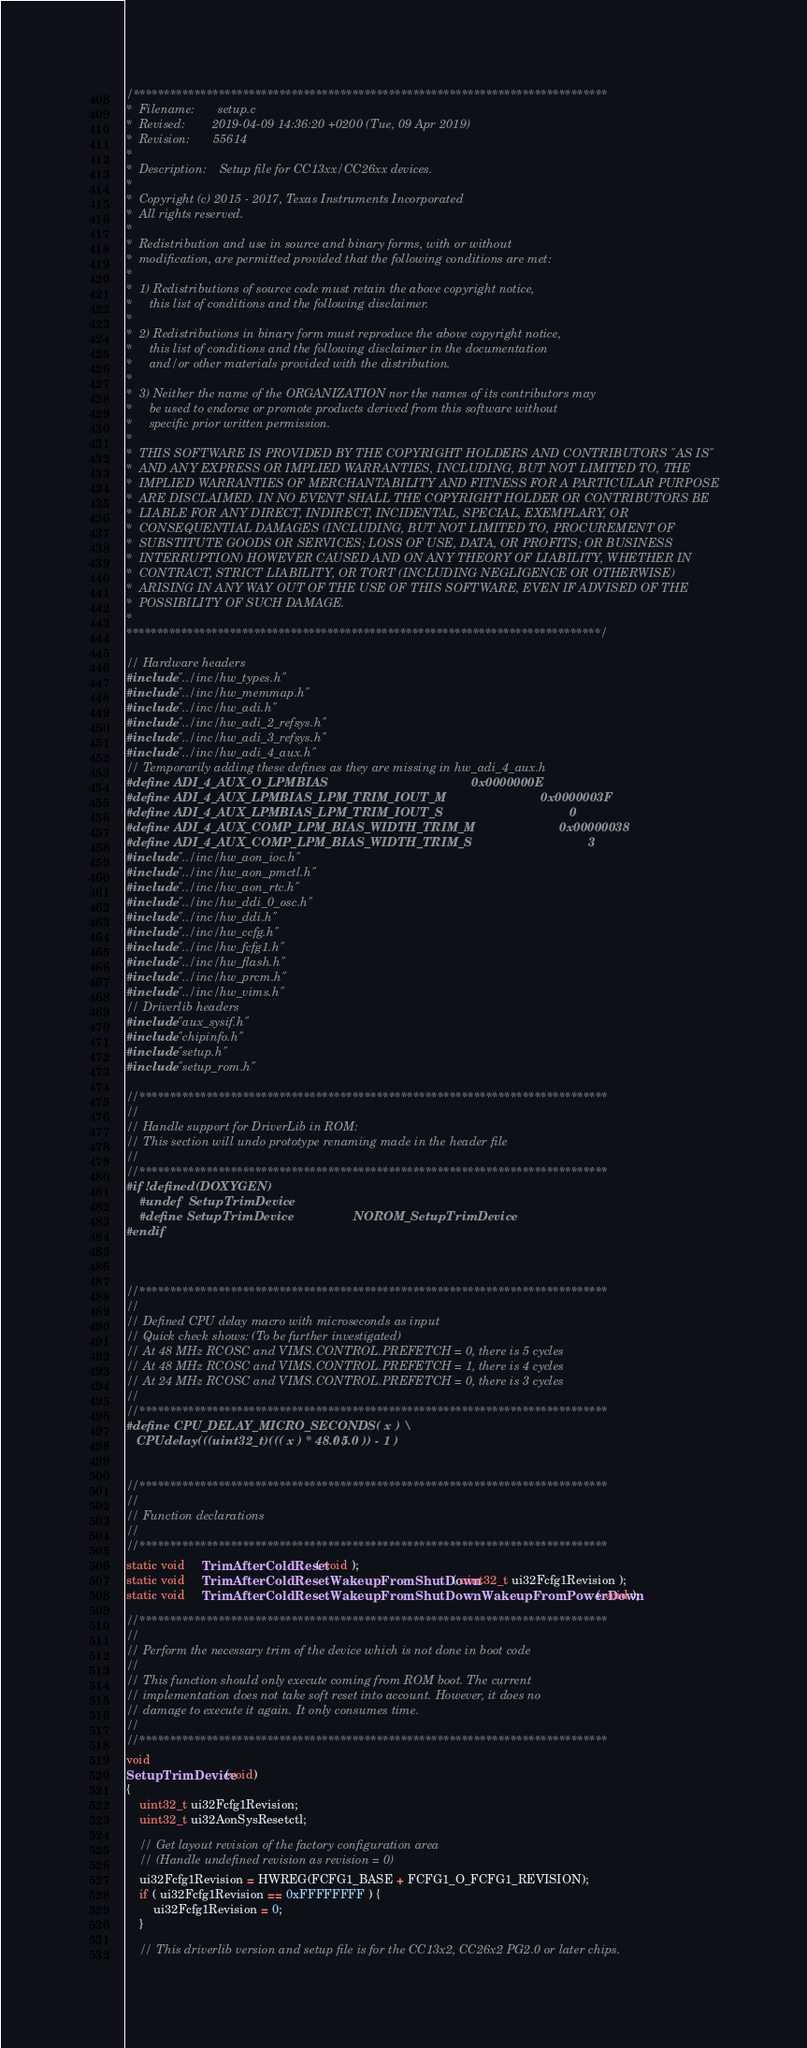Convert code to text. <code><loc_0><loc_0><loc_500><loc_500><_C_>/******************************************************************************
*  Filename:       setup.c
*  Revised:        2019-04-09 14:36:20 +0200 (Tue, 09 Apr 2019)
*  Revision:       55614
*
*  Description:    Setup file for CC13xx/CC26xx devices.
*
*  Copyright (c) 2015 - 2017, Texas Instruments Incorporated
*  All rights reserved.
*
*  Redistribution and use in source and binary forms, with or without
*  modification, are permitted provided that the following conditions are met:
*
*  1) Redistributions of source code must retain the above copyright notice,
*     this list of conditions and the following disclaimer.
*
*  2) Redistributions in binary form must reproduce the above copyright notice,
*     this list of conditions and the following disclaimer in the documentation
*     and/or other materials provided with the distribution.
*
*  3) Neither the name of the ORGANIZATION nor the names of its contributors may
*     be used to endorse or promote products derived from this software without
*     specific prior written permission.
*
*  THIS SOFTWARE IS PROVIDED BY THE COPYRIGHT HOLDERS AND CONTRIBUTORS "AS IS"
*  AND ANY EXPRESS OR IMPLIED WARRANTIES, INCLUDING, BUT NOT LIMITED TO, THE
*  IMPLIED WARRANTIES OF MERCHANTABILITY AND FITNESS FOR A PARTICULAR PURPOSE
*  ARE DISCLAIMED. IN NO EVENT SHALL THE COPYRIGHT HOLDER OR CONTRIBUTORS BE
*  LIABLE FOR ANY DIRECT, INDIRECT, INCIDENTAL, SPECIAL, EXEMPLARY, OR
*  CONSEQUENTIAL DAMAGES (INCLUDING, BUT NOT LIMITED TO, PROCUREMENT OF
*  SUBSTITUTE GOODS OR SERVICES; LOSS OF USE, DATA, OR PROFITS; OR BUSINESS
*  INTERRUPTION) HOWEVER CAUSED AND ON ANY THEORY OF LIABILITY, WHETHER IN
*  CONTRACT, STRICT LIABILITY, OR TORT (INCLUDING NEGLIGENCE OR OTHERWISE)
*  ARISING IN ANY WAY OUT OF THE USE OF THIS SOFTWARE, EVEN IF ADVISED OF THE
*  POSSIBILITY OF SUCH DAMAGE.
*
******************************************************************************/

// Hardware headers
#include "../inc/hw_types.h"
#include "../inc/hw_memmap.h"
#include "../inc/hw_adi.h"
#include "../inc/hw_adi_2_refsys.h"
#include "../inc/hw_adi_3_refsys.h"
#include "../inc/hw_adi_4_aux.h"
// Temporarily adding these defines as they are missing in hw_adi_4_aux.h
#define ADI_4_AUX_O_LPMBIAS                                         0x0000000E
#define ADI_4_AUX_LPMBIAS_LPM_TRIM_IOUT_M                           0x0000003F
#define ADI_4_AUX_LPMBIAS_LPM_TRIM_IOUT_S                                    0
#define ADI_4_AUX_COMP_LPM_BIAS_WIDTH_TRIM_M                        0x00000038
#define ADI_4_AUX_COMP_LPM_BIAS_WIDTH_TRIM_S                                 3
#include "../inc/hw_aon_ioc.h"
#include "../inc/hw_aon_pmctl.h"
#include "../inc/hw_aon_rtc.h"
#include "../inc/hw_ddi_0_osc.h"
#include "../inc/hw_ddi.h"
#include "../inc/hw_ccfg.h"
#include "../inc/hw_fcfg1.h"
#include "../inc/hw_flash.h"
#include "../inc/hw_prcm.h"
#include "../inc/hw_vims.h"
// Driverlib headers
#include "aux_sysif.h"
#include "chipinfo.h"
#include "setup.h"
#include "setup_rom.h"

//*****************************************************************************
//
// Handle support for DriverLib in ROM:
// This section will undo prototype renaming made in the header file
//
//*****************************************************************************
#if !defined(DOXYGEN)
    #undef  SetupTrimDevice
    #define SetupTrimDevice                 NOROM_SetupTrimDevice
#endif



//*****************************************************************************
//
// Defined CPU delay macro with microseconds as input
// Quick check shows: (To be further investigated)
// At 48 MHz RCOSC and VIMS.CONTROL.PREFETCH = 0, there is 5 cycles
// At 48 MHz RCOSC and VIMS.CONTROL.PREFETCH = 1, there is 4 cycles
// At 24 MHz RCOSC and VIMS.CONTROL.PREFETCH = 0, there is 3 cycles
//
//*****************************************************************************
#define CPU_DELAY_MICRO_SECONDS( x ) \
   CPUdelay(((uint32_t)((( x ) * 48.0 ) / 5.0 )) - 1 )


//*****************************************************************************
//
// Function declarations
//
//*****************************************************************************
static void     TrimAfterColdReset( void );
static void     TrimAfterColdResetWakeupFromShutDown( uint32_t ui32Fcfg1Revision );
static void     TrimAfterColdResetWakeupFromShutDownWakeupFromPowerDown( void );

//*****************************************************************************
//
// Perform the necessary trim of the device which is not done in boot code
//
// This function should only execute coming from ROM boot. The current
// implementation does not take soft reset into account. However, it does no
// damage to execute it again. It only consumes time.
//
//*****************************************************************************
void
SetupTrimDevice(void)
{
    uint32_t ui32Fcfg1Revision;
    uint32_t ui32AonSysResetctl;

    // Get layout revision of the factory configuration area
    // (Handle undefined revision as revision = 0)
    ui32Fcfg1Revision = HWREG(FCFG1_BASE + FCFG1_O_FCFG1_REVISION);
    if ( ui32Fcfg1Revision == 0xFFFFFFFF ) {
        ui32Fcfg1Revision = 0;
    }

    // This driverlib version and setup file is for the CC13x2, CC26x2 PG2.0 or later chips.</code> 